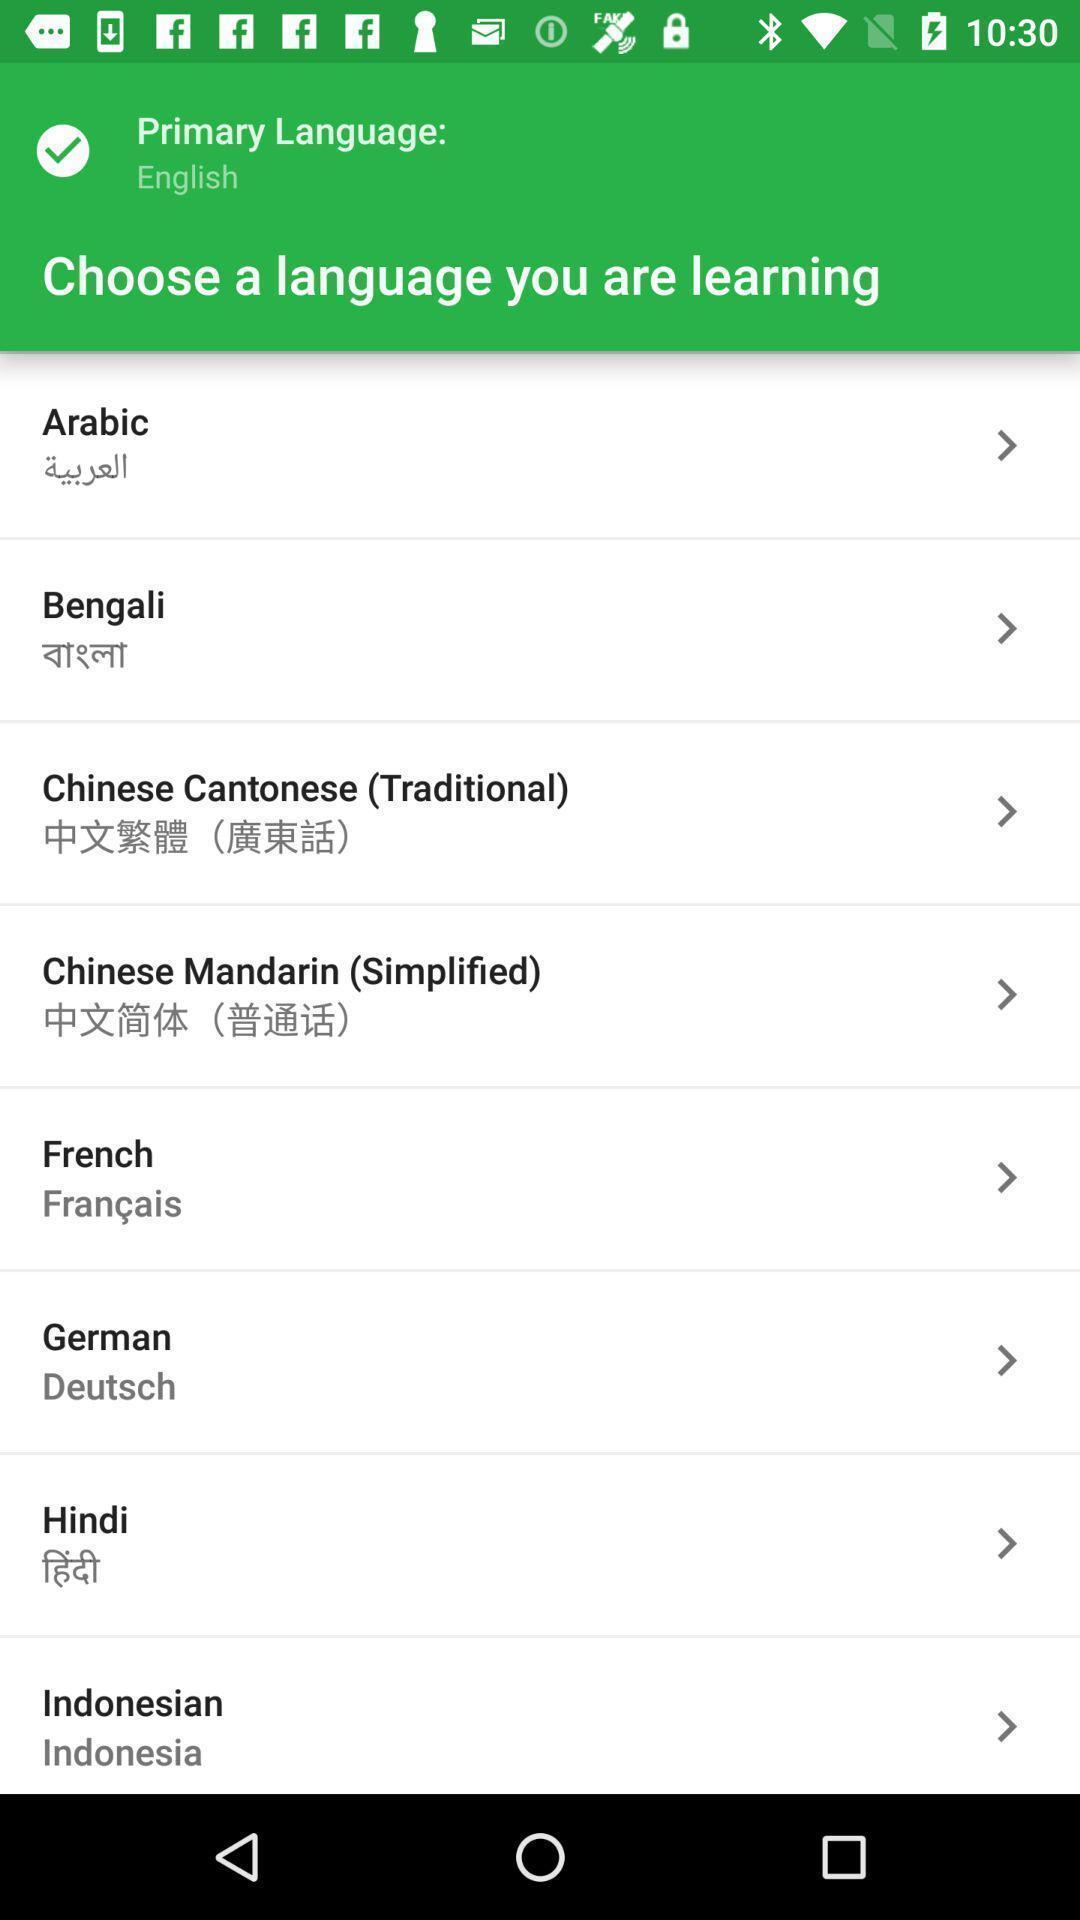Tell me what you see in this picture. Page showing different languages to select. 